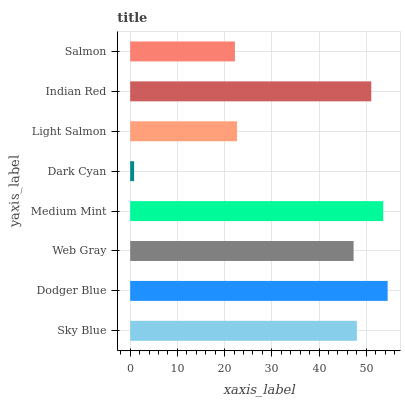Is Dark Cyan the minimum?
Answer yes or no. Yes. Is Dodger Blue the maximum?
Answer yes or no. Yes. Is Web Gray the minimum?
Answer yes or no. No. Is Web Gray the maximum?
Answer yes or no. No. Is Dodger Blue greater than Web Gray?
Answer yes or no. Yes. Is Web Gray less than Dodger Blue?
Answer yes or no. Yes. Is Web Gray greater than Dodger Blue?
Answer yes or no. No. Is Dodger Blue less than Web Gray?
Answer yes or no. No. Is Sky Blue the high median?
Answer yes or no. Yes. Is Web Gray the low median?
Answer yes or no. Yes. Is Web Gray the high median?
Answer yes or no. No. Is Medium Mint the low median?
Answer yes or no. No. 